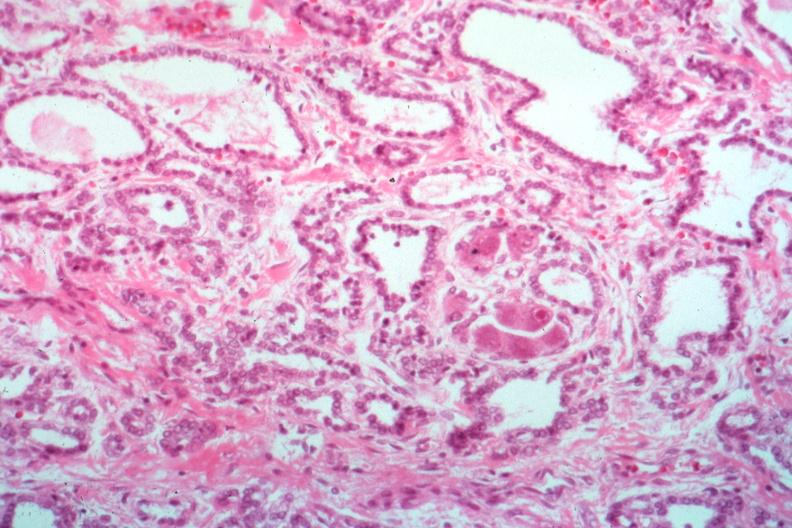s carcinomatosis present?
Answer the question using a single word or phrase. No 